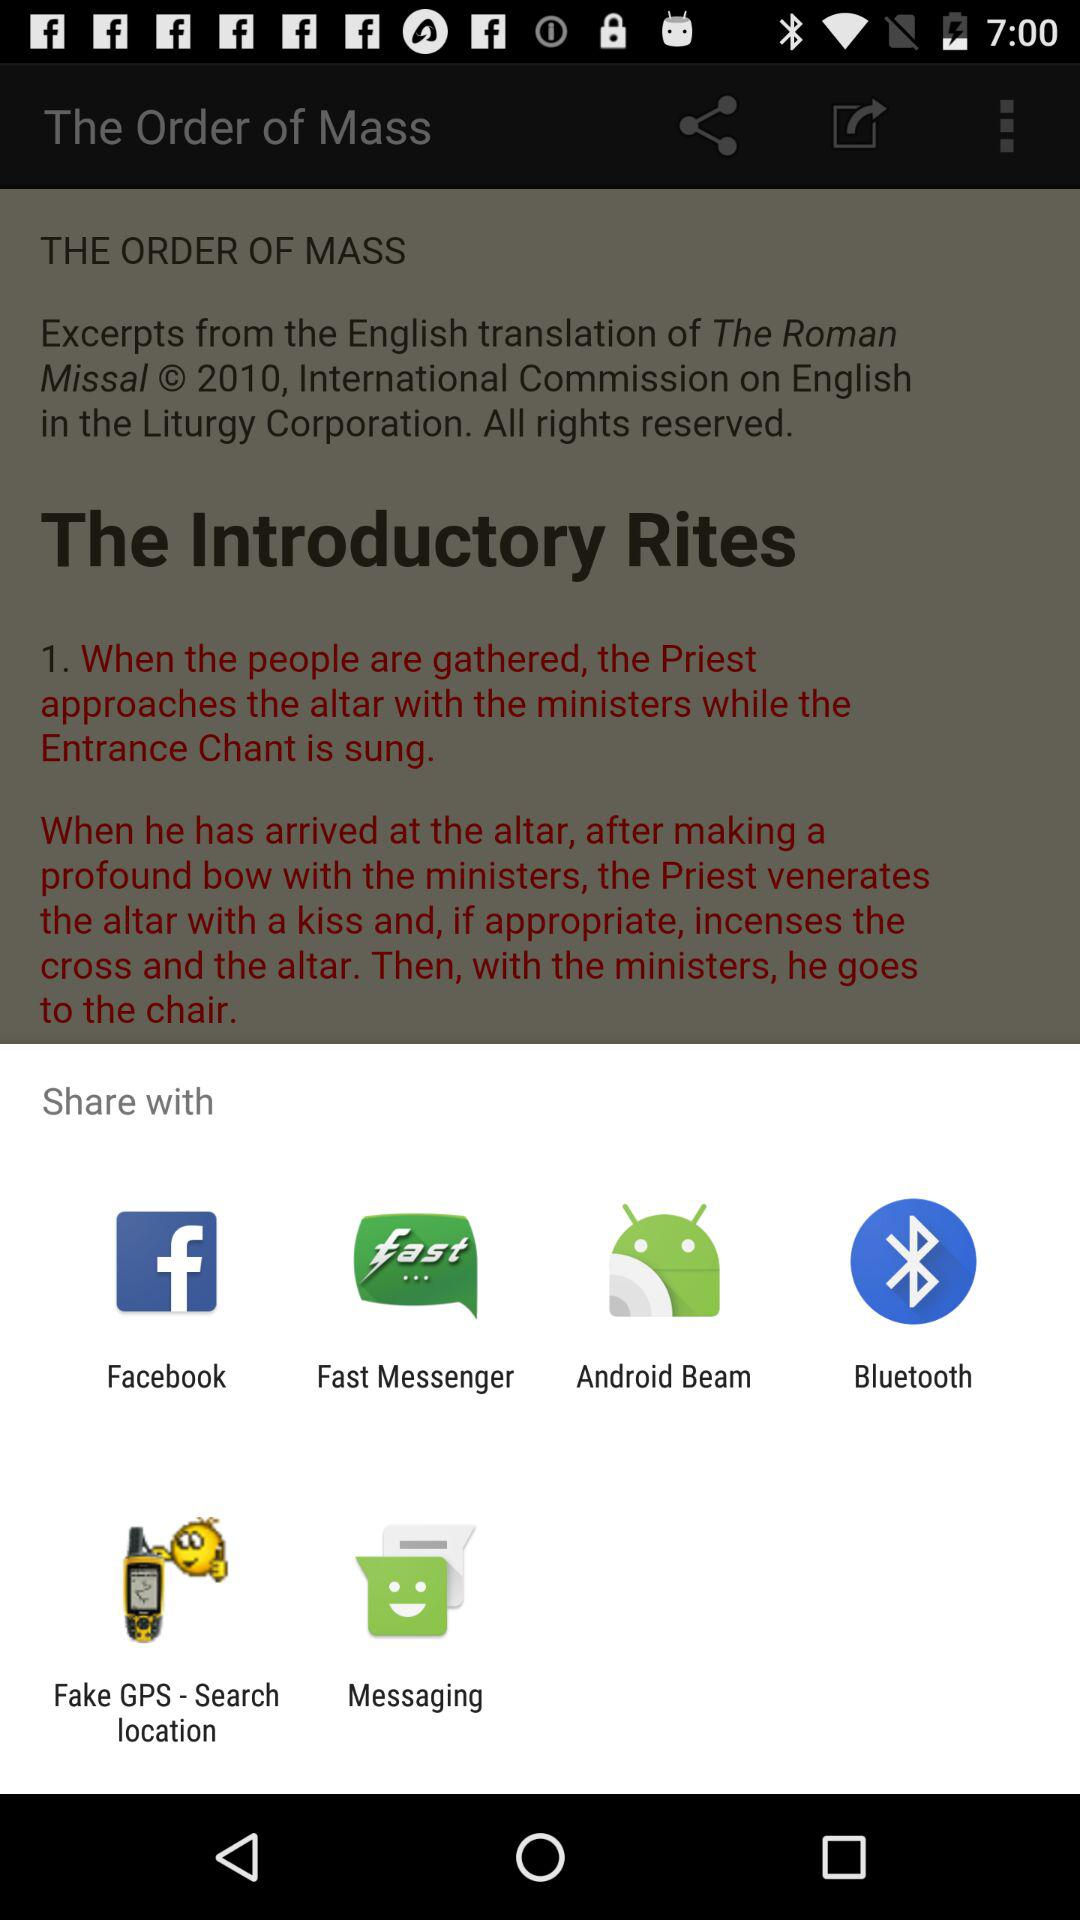When were the introductory rites first put into practice?
When the provided information is insufficient, respond with <no answer>. <no answer> 